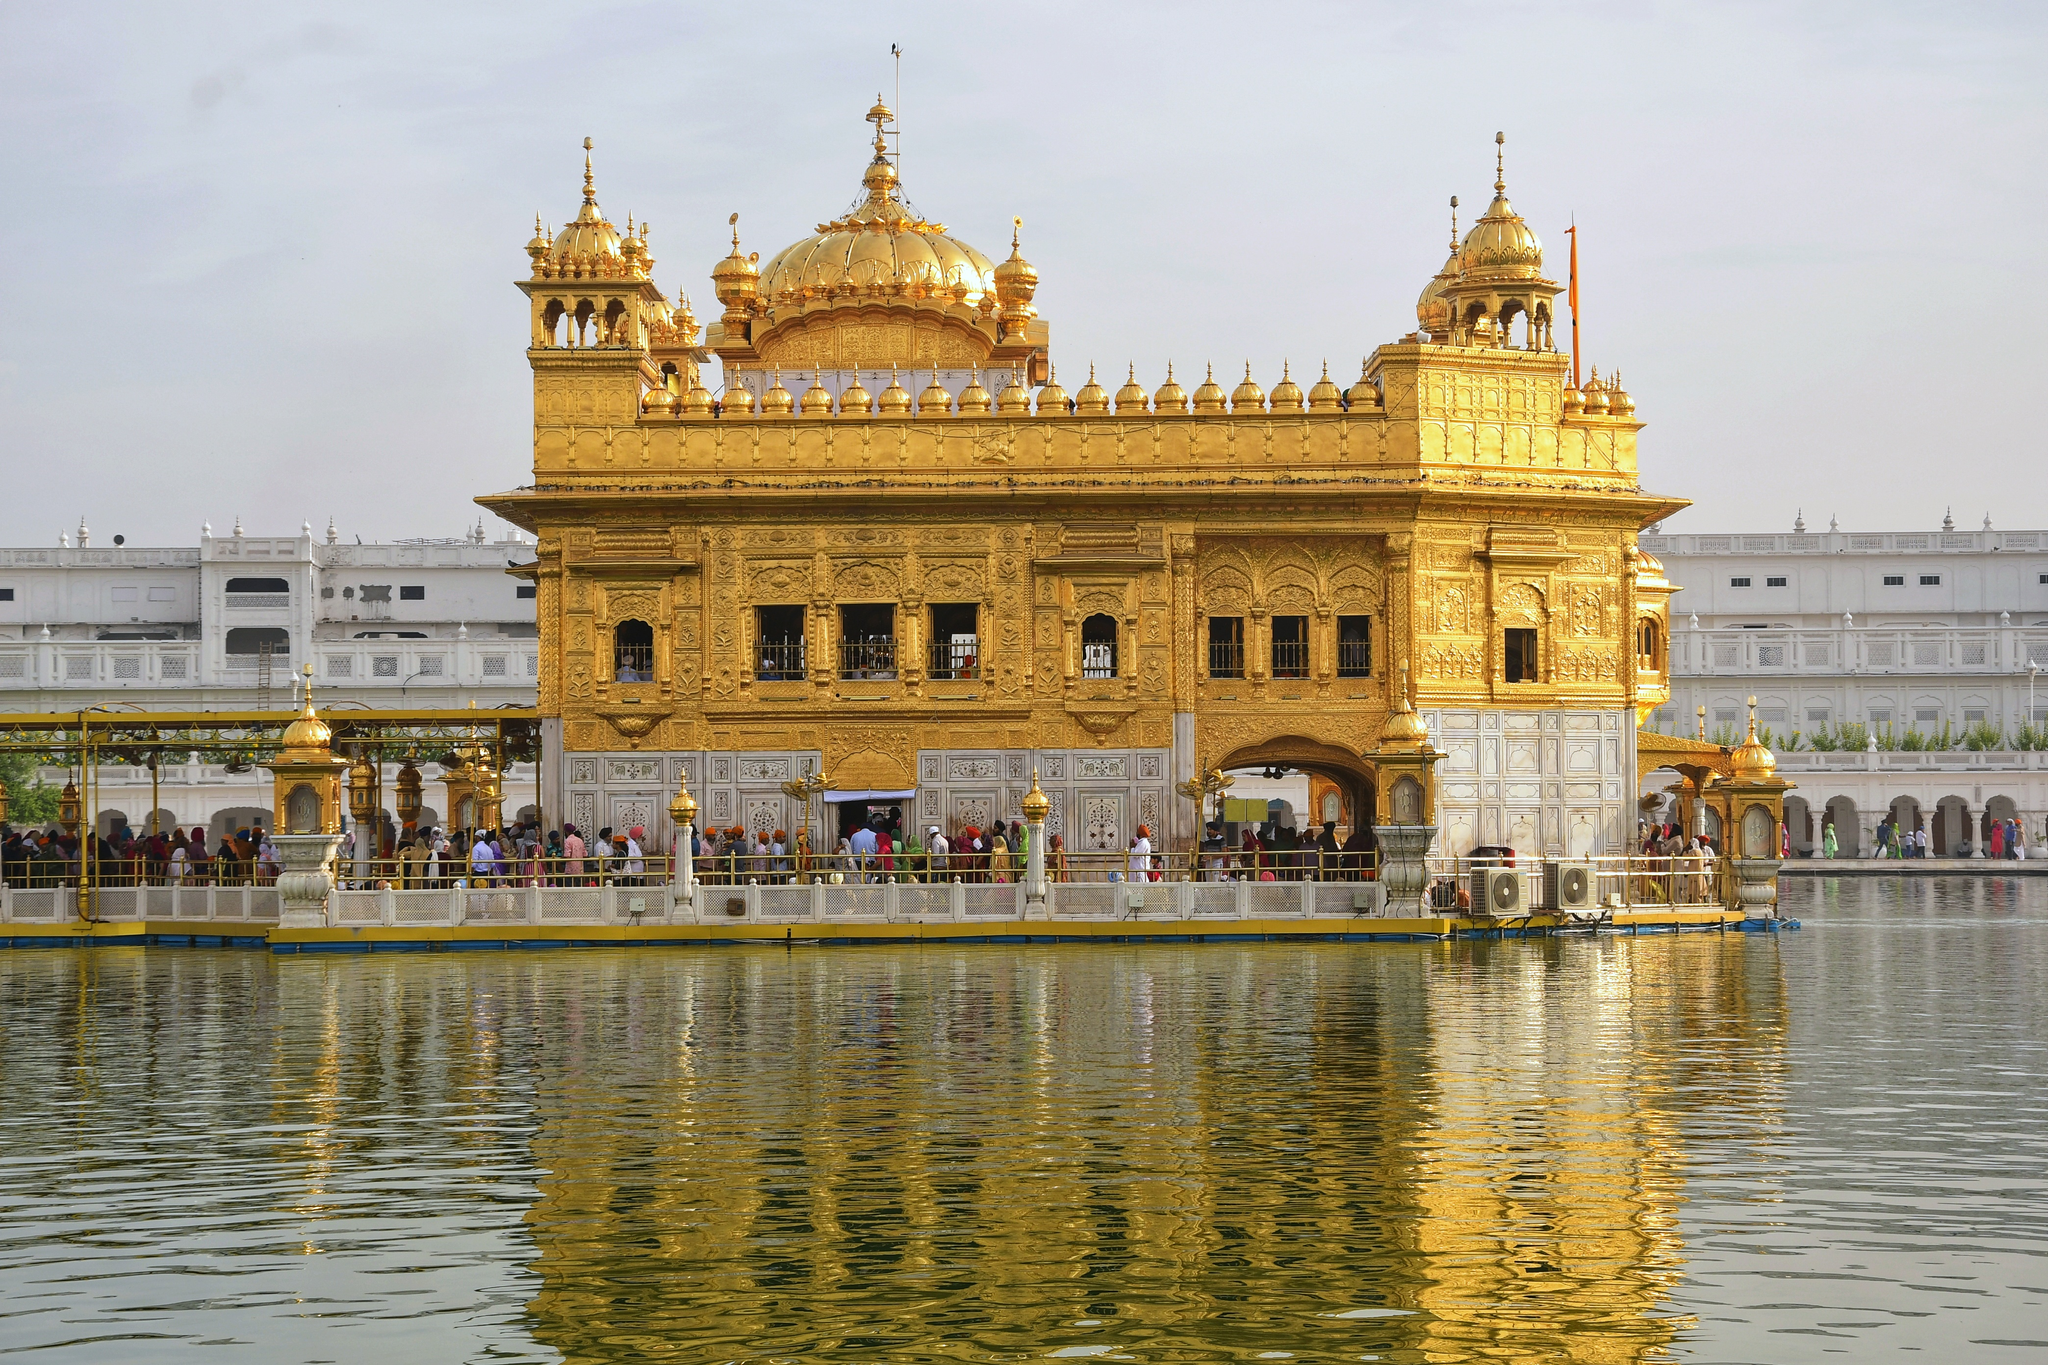If the Golden Temple could speak, what stories do you think it would tell? If the Golden Temple could speak, it would tell tales of faith, resilience, and unity. It would recount the countless devotees who have walked its paths, seeking solace, offering prayers, and finding peace. It would share stories of the community's unwavering spirit during times of turmoil, and the sanctuary it provided during periods of persecution. The temple would narrate the construction efforts, led by Guru Arjan Dev, and the subsequent additions by Maharaja Ranjit Singh. It would celebrate the daily acts of kindness and the tireless 'Seva' performed in its Langar halls, reflecting the spirit of Sikhism. The temple stands as a testament to the strength of a community bound by faith, love, and a commitment to serving humanity. What mysteries lie within the Golden Temple that have yet to be discovered? Beneath the golden facade of the Golden Temple lie centuries-old mysteries, waiting to unravel. Hidden passages and rooms, used during historical conflicts, may still hold secrets of the past. Ancient manuscripts and scriptures, some yet unexplored, lie within, potentially offering new insights into Sikh philosophy and history. The structural ingenuity of the temple, with its blend of Indo-Islamic and traditional Sikh architecture, could reveal lost techniques and forgotten artistry. Spiritual mysteries abound as well, with countless tales of divine encounters and miraculous interventions adding an enigmatic aura to this hallowed sanctuary. 